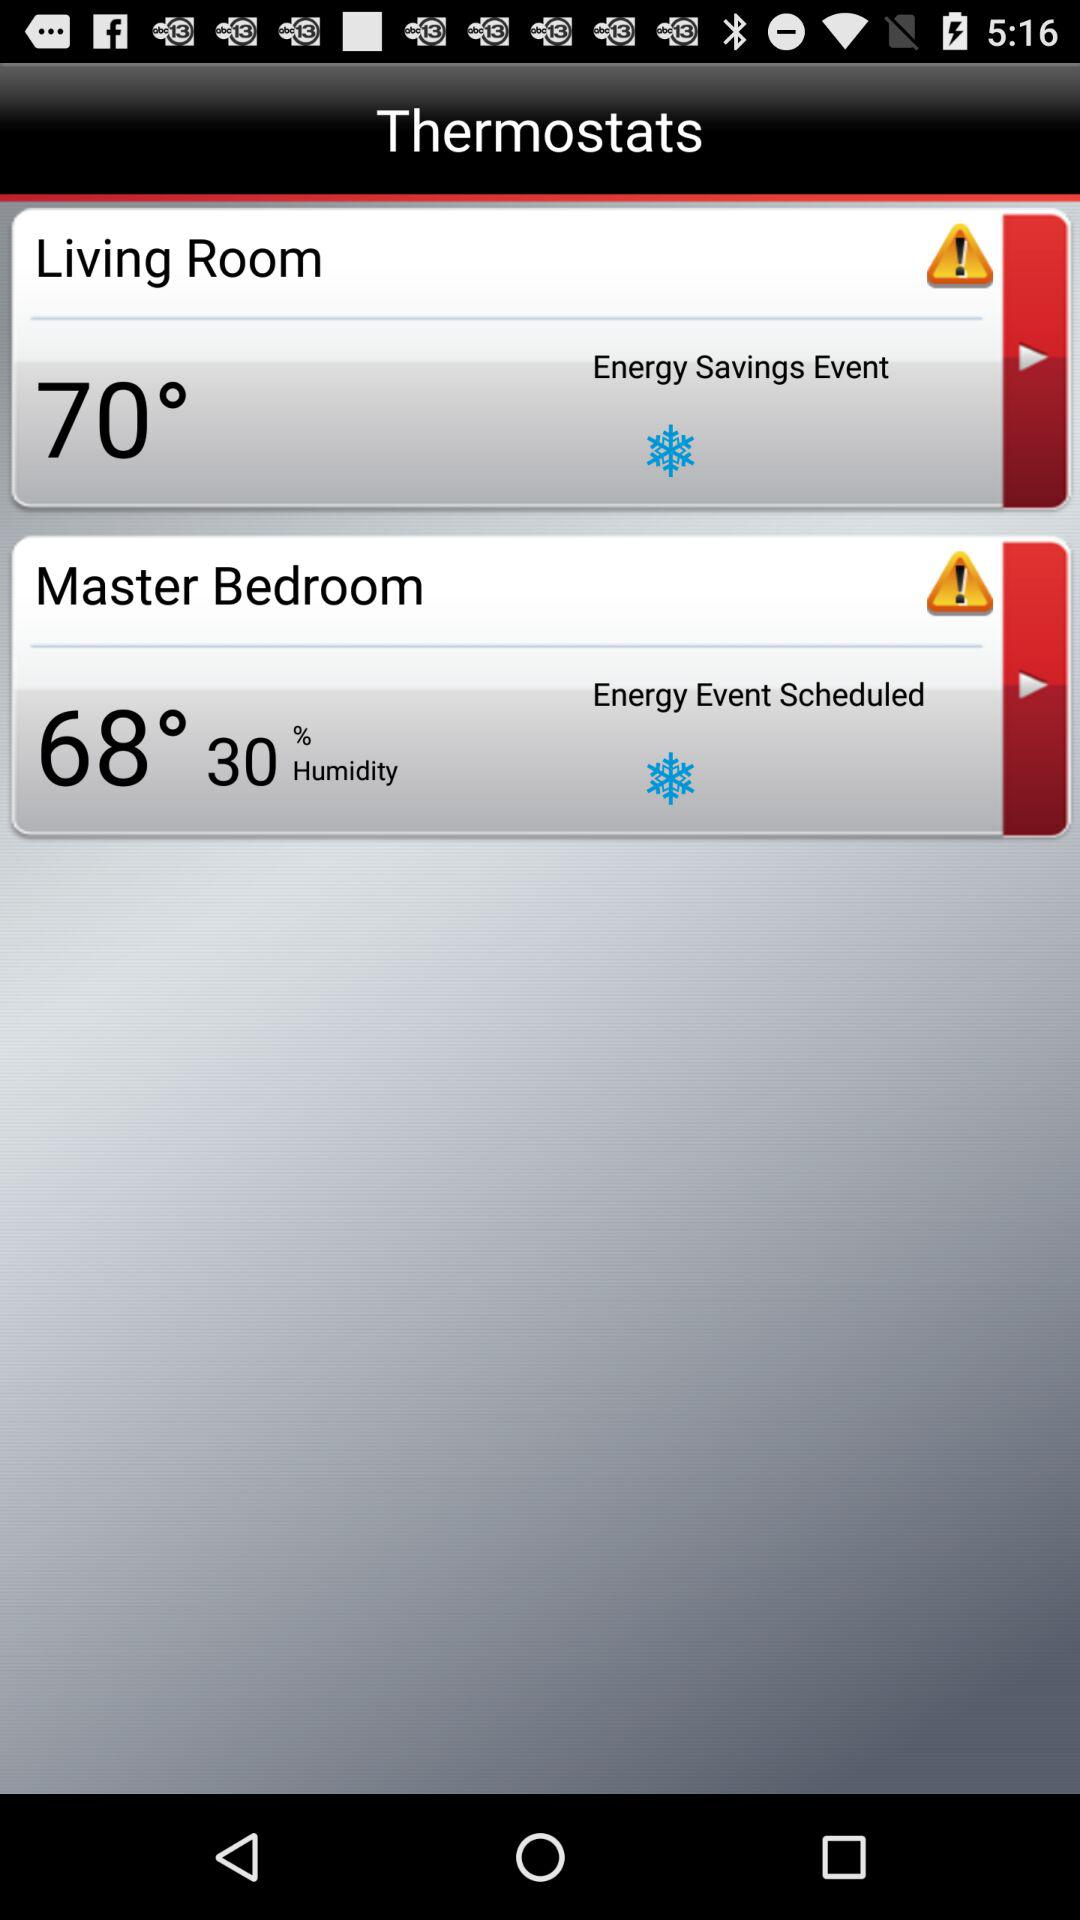How much is the humidity in the master bedroom? The humidity in the master bedroom is 30%. 